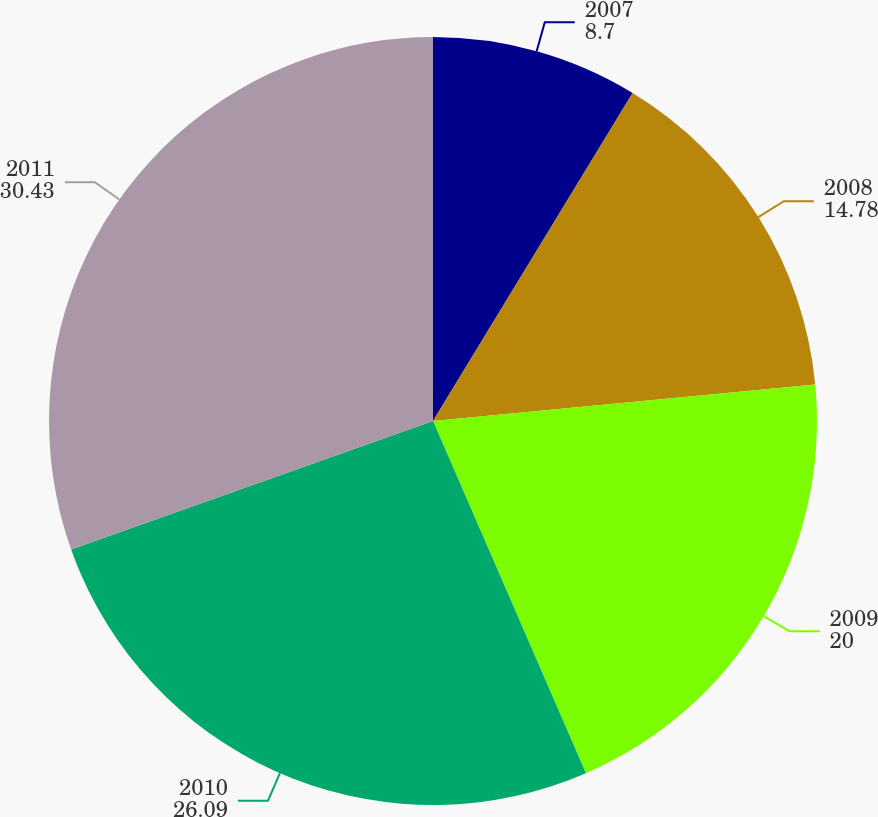<chart> <loc_0><loc_0><loc_500><loc_500><pie_chart><fcel>2007<fcel>2008<fcel>2009<fcel>2010<fcel>2011<nl><fcel>8.7%<fcel>14.78%<fcel>20.0%<fcel>26.09%<fcel>30.43%<nl></chart> 